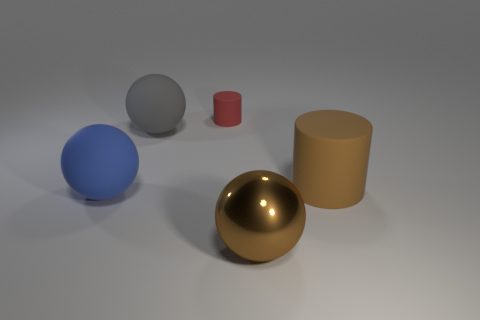What is the shape of the other blue thing that is the same size as the metallic object?
Your answer should be very brief. Sphere. There is a rubber object in front of the large matte thing right of the tiny matte thing; is there a brown cylinder that is on the right side of it?
Provide a succinct answer. Yes. Are there any other blue rubber balls of the same size as the blue ball?
Provide a succinct answer. No. There is a matte ball that is behind the blue rubber object; how big is it?
Provide a short and direct response. Large. The large rubber sphere that is behind the matte sphere in front of the rubber cylinder in front of the small rubber thing is what color?
Your answer should be compact. Gray. There is a rubber cylinder that is to the right of the big ball in front of the big blue rubber object; what is its color?
Provide a short and direct response. Brown. Are there more small cylinders left of the red object than shiny spheres behind the blue matte object?
Provide a succinct answer. No. Are the large ball right of the tiny cylinder and the large sphere to the left of the gray rubber ball made of the same material?
Offer a terse response. No. There is a large brown rubber object; are there any blue matte objects to the right of it?
Offer a terse response. No. What number of red things are small matte objects or matte cylinders?
Give a very brief answer. 1. 